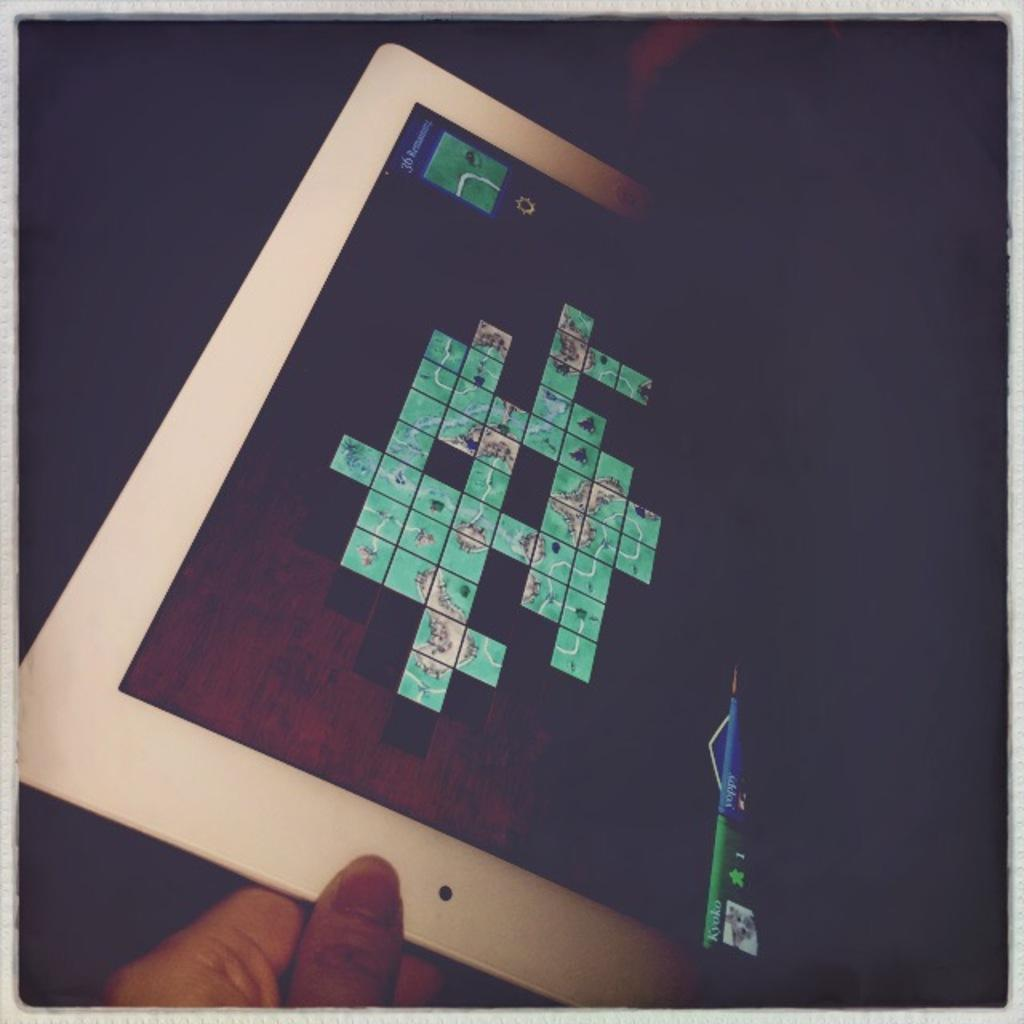What can be seen in the image? There is a person in the image. What is the person holding? The person is holding a gadget. What is displayed on the screen of the gadget? There is a game on the screen of the gadget. What type of winter clothing is the person wearing in the image? The image does not show the person wearing any winter clothing, as there is no reference to winter or cold weather in the provided facts. 